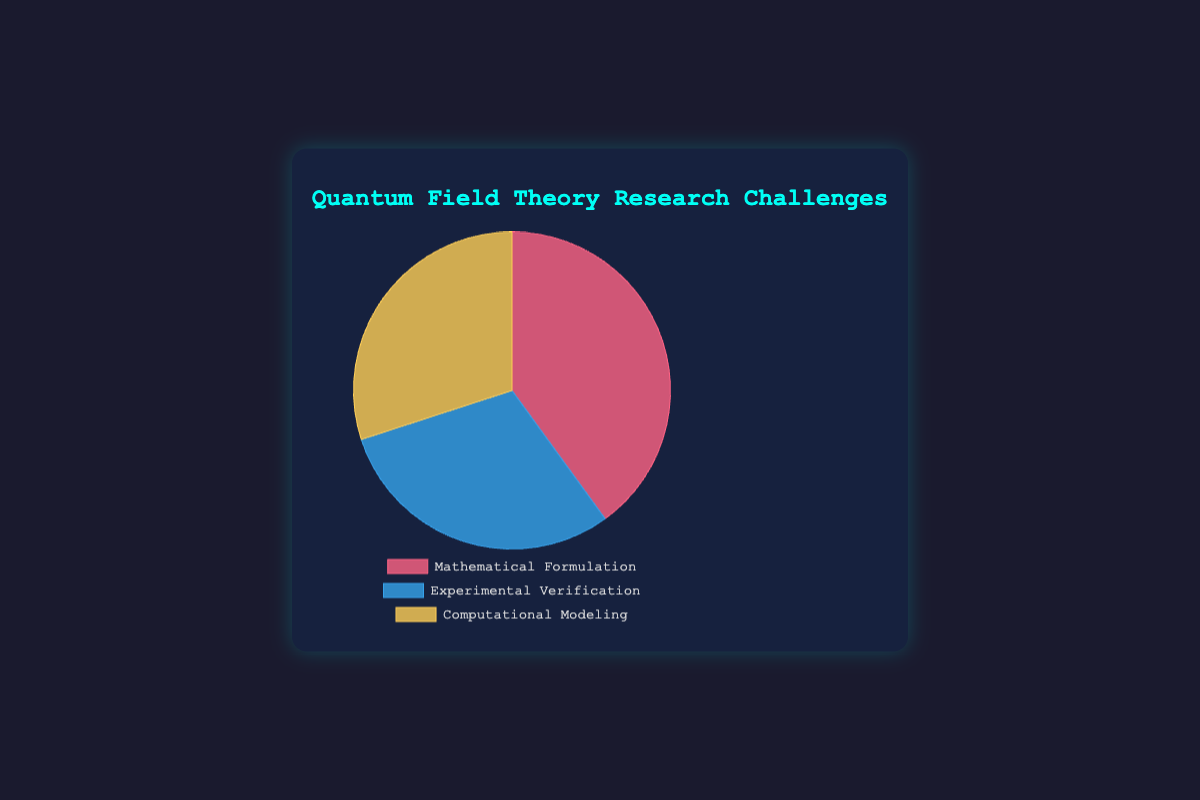Which research challenge has the greatest contribution percentage? The chart shows that the "Mathematical Formulation" section occupies the largest portion of the pie chart.
Answer: Mathematical Formulation Which two research challenges have equal contribution percentages? By examining the pie chart, it can be seen that both "Experimental Verification" and "Computational Modeling" have equal sizes, indicating they contribute the same percentage.
Answer: Experimental Verification and Computational Modeling What is the total contribution percentage of "Experimental Verification" and "Computational Modeling" combined? From the chart, "Experimental Verification" and "Computational Modeling" each contribute 30%. Adding these percentages together gives 30% + 30% = 60%.
Answer: 60% Is the contribution percentage of "Mathematical Formulation" greater than or less than the sum of "Experimental Verification" and "Computational Modeling"? The contribution percentage for "Mathematical Formulation" is 40%, whereas the sum of "Experimental Verification" and "Computational Modeling" is 30% + 30% = 60%. 40% is less than 60%.
Answer: Less than Which color represents the "Computational Modeling" challenge on the pie chart? The section for "Computational Modeling" is filled with a yellow color on the chart.
Answer: Yellow What percentage of the chart is not dedicated to "Mathematical Formulation"? Since "Mathematical Formulation" contributes 40%, the remaining percentage is 100% - 40% = 60%.
Answer: 60% How much larger in terms of percentage is the "Mathematical Formulation" contribution compared to each of the other challenges? "Mathematical Formulation" contributes 40%, while both "Experimental Verification" and "Computational Modeling" each contribute 30%. Therefore, "Mathematical Formulation" is 40% - 30% = 10% larger than each of the other two challenges.
Answer: 10% What is the average contribution percentage of all three research challenges? The contributions are 40%, 30%, and 30%. The average is calculated as (40 + 30 + 30) / 3 = 100 / 3 ≈ 33.33%.
Answer: 33.33% 